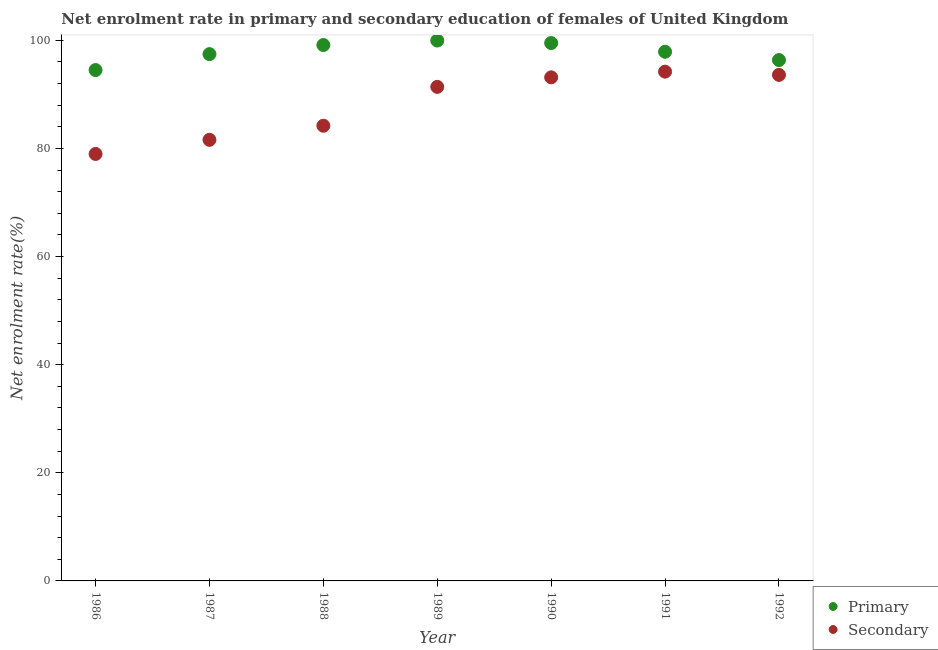What is the enrollment rate in primary education in 1987?
Provide a short and direct response. 97.44. Across all years, what is the maximum enrollment rate in secondary education?
Offer a terse response. 94.19. Across all years, what is the minimum enrollment rate in secondary education?
Offer a very short reply. 78.97. In which year was the enrollment rate in primary education maximum?
Keep it short and to the point. 1989. What is the total enrollment rate in secondary education in the graph?
Ensure brevity in your answer.  617.06. What is the difference between the enrollment rate in primary education in 1987 and that in 1988?
Give a very brief answer. -1.68. What is the difference between the enrollment rate in secondary education in 1989 and the enrollment rate in primary education in 1986?
Offer a very short reply. -3.11. What is the average enrollment rate in primary education per year?
Keep it short and to the point. 97.81. In the year 1988, what is the difference between the enrollment rate in primary education and enrollment rate in secondary education?
Your response must be concise. 14.93. In how many years, is the enrollment rate in primary education greater than 4 %?
Offer a terse response. 7. What is the ratio of the enrollment rate in secondary education in 1988 to that in 1989?
Your response must be concise. 0.92. Is the enrollment rate in secondary education in 1987 less than that in 1992?
Your answer should be compact. Yes. What is the difference between the highest and the second highest enrollment rate in secondary education?
Offer a terse response. 0.6. What is the difference between the highest and the lowest enrollment rate in secondary education?
Your response must be concise. 15.22. Is the sum of the enrollment rate in primary education in 1988 and 1992 greater than the maximum enrollment rate in secondary education across all years?
Offer a terse response. Yes. Does the enrollment rate in primary education monotonically increase over the years?
Make the answer very short. No. Is the enrollment rate in secondary education strictly greater than the enrollment rate in primary education over the years?
Your response must be concise. No. Is the enrollment rate in secondary education strictly less than the enrollment rate in primary education over the years?
Give a very brief answer. Yes. How many years are there in the graph?
Ensure brevity in your answer.  7. What is the difference between two consecutive major ticks on the Y-axis?
Your response must be concise. 20. Are the values on the major ticks of Y-axis written in scientific E-notation?
Ensure brevity in your answer.  No. Does the graph contain any zero values?
Keep it short and to the point. No. What is the title of the graph?
Offer a terse response. Net enrolment rate in primary and secondary education of females of United Kingdom. Does "Private consumption" appear as one of the legend labels in the graph?
Make the answer very short. No. What is the label or title of the X-axis?
Your response must be concise. Year. What is the label or title of the Y-axis?
Your answer should be very brief. Net enrolment rate(%). What is the Net enrolment rate(%) of Primary in 1986?
Give a very brief answer. 94.49. What is the Net enrolment rate(%) in Secondary in 1986?
Provide a short and direct response. 78.97. What is the Net enrolment rate(%) of Primary in 1987?
Offer a very short reply. 97.44. What is the Net enrolment rate(%) in Secondary in 1987?
Ensure brevity in your answer.  81.59. What is the Net enrolment rate(%) of Primary in 1988?
Your answer should be very brief. 99.12. What is the Net enrolment rate(%) in Secondary in 1988?
Your answer should be compact. 84.19. What is the Net enrolment rate(%) of Primary in 1989?
Ensure brevity in your answer.  99.95. What is the Net enrolment rate(%) in Secondary in 1989?
Keep it short and to the point. 91.38. What is the Net enrolment rate(%) of Primary in 1990?
Make the answer very short. 99.48. What is the Net enrolment rate(%) of Secondary in 1990?
Your answer should be compact. 93.14. What is the Net enrolment rate(%) of Primary in 1991?
Your answer should be very brief. 97.87. What is the Net enrolment rate(%) of Secondary in 1991?
Your response must be concise. 94.19. What is the Net enrolment rate(%) of Primary in 1992?
Provide a succinct answer. 96.34. What is the Net enrolment rate(%) of Secondary in 1992?
Make the answer very short. 93.59. Across all years, what is the maximum Net enrolment rate(%) in Primary?
Provide a short and direct response. 99.95. Across all years, what is the maximum Net enrolment rate(%) of Secondary?
Your answer should be very brief. 94.19. Across all years, what is the minimum Net enrolment rate(%) of Primary?
Offer a terse response. 94.49. Across all years, what is the minimum Net enrolment rate(%) in Secondary?
Your answer should be very brief. 78.97. What is the total Net enrolment rate(%) of Primary in the graph?
Offer a terse response. 684.69. What is the total Net enrolment rate(%) of Secondary in the graph?
Offer a very short reply. 617.06. What is the difference between the Net enrolment rate(%) in Primary in 1986 and that in 1987?
Your answer should be very brief. -2.95. What is the difference between the Net enrolment rate(%) in Secondary in 1986 and that in 1987?
Give a very brief answer. -2.61. What is the difference between the Net enrolment rate(%) of Primary in 1986 and that in 1988?
Offer a terse response. -4.63. What is the difference between the Net enrolment rate(%) in Secondary in 1986 and that in 1988?
Provide a short and direct response. -5.22. What is the difference between the Net enrolment rate(%) in Primary in 1986 and that in 1989?
Your answer should be very brief. -5.46. What is the difference between the Net enrolment rate(%) in Secondary in 1986 and that in 1989?
Keep it short and to the point. -12.41. What is the difference between the Net enrolment rate(%) in Primary in 1986 and that in 1990?
Offer a very short reply. -4.99. What is the difference between the Net enrolment rate(%) of Secondary in 1986 and that in 1990?
Provide a succinct answer. -14.17. What is the difference between the Net enrolment rate(%) in Primary in 1986 and that in 1991?
Provide a short and direct response. -3.38. What is the difference between the Net enrolment rate(%) of Secondary in 1986 and that in 1991?
Keep it short and to the point. -15.22. What is the difference between the Net enrolment rate(%) in Primary in 1986 and that in 1992?
Your answer should be very brief. -1.85. What is the difference between the Net enrolment rate(%) of Secondary in 1986 and that in 1992?
Your answer should be very brief. -14.62. What is the difference between the Net enrolment rate(%) of Primary in 1987 and that in 1988?
Give a very brief answer. -1.68. What is the difference between the Net enrolment rate(%) in Secondary in 1987 and that in 1988?
Your answer should be compact. -2.61. What is the difference between the Net enrolment rate(%) in Primary in 1987 and that in 1989?
Provide a succinct answer. -2.51. What is the difference between the Net enrolment rate(%) in Secondary in 1987 and that in 1989?
Keep it short and to the point. -9.79. What is the difference between the Net enrolment rate(%) of Primary in 1987 and that in 1990?
Offer a terse response. -2.05. What is the difference between the Net enrolment rate(%) of Secondary in 1987 and that in 1990?
Your answer should be compact. -11.56. What is the difference between the Net enrolment rate(%) of Primary in 1987 and that in 1991?
Give a very brief answer. -0.43. What is the difference between the Net enrolment rate(%) in Secondary in 1987 and that in 1991?
Your answer should be compact. -12.61. What is the difference between the Net enrolment rate(%) of Primary in 1987 and that in 1992?
Offer a terse response. 1.1. What is the difference between the Net enrolment rate(%) of Secondary in 1987 and that in 1992?
Provide a short and direct response. -12.01. What is the difference between the Net enrolment rate(%) in Primary in 1988 and that in 1989?
Ensure brevity in your answer.  -0.83. What is the difference between the Net enrolment rate(%) in Secondary in 1988 and that in 1989?
Provide a succinct answer. -7.19. What is the difference between the Net enrolment rate(%) in Primary in 1988 and that in 1990?
Make the answer very short. -0.37. What is the difference between the Net enrolment rate(%) in Secondary in 1988 and that in 1990?
Provide a succinct answer. -8.95. What is the difference between the Net enrolment rate(%) in Primary in 1988 and that in 1991?
Offer a very short reply. 1.25. What is the difference between the Net enrolment rate(%) in Secondary in 1988 and that in 1991?
Ensure brevity in your answer.  -10. What is the difference between the Net enrolment rate(%) in Primary in 1988 and that in 1992?
Give a very brief answer. 2.78. What is the difference between the Net enrolment rate(%) of Secondary in 1988 and that in 1992?
Your answer should be compact. -9.4. What is the difference between the Net enrolment rate(%) of Primary in 1989 and that in 1990?
Provide a succinct answer. 0.46. What is the difference between the Net enrolment rate(%) in Secondary in 1989 and that in 1990?
Offer a terse response. -1.76. What is the difference between the Net enrolment rate(%) of Primary in 1989 and that in 1991?
Provide a succinct answer. 2.08. What is the difference between the Net enrolment rate(%) in Secondary in 1989 and that in 1991?
Ensure brevity in your answer.  -2.82. What is the difference between the Net enrolment rate(%) in Primary in 1989 and that in 1992?
Keep it short and to the point. 3.61. What is the difference between the Net enrolment rate(%) of Secondary in 1989 and that in 1992?
Provide a short and direct response. -2.22. What is the difference between the Net enrolment rate(%) of Primary in 1990 and that in 1991?
Your response must be concise. 1.61. What is the difference between the Net enrolment rate(%) of Secondary in 1990 and that in 1991?
Offer a terse response. -1.05. What is the difference between the Net enrolment rate(%) in Primary in 1990 and that in 1992?
Make the answer very short. 3.15. What is the difference between the Net enrolment rate(%) in Secondary in 1990 and that in 1992?
Provide a short and direct response. -0.45. What is the difference between the Net enrolment rate(%) of Primary in 1991 and that in 1992?
Make the answer very short. 1.53. What is the difference between the Net enrolment rate(%) of Secondary in 1991 and that in 1992?
Ensure brevity in your answer.  0.6. What is the difference between the Net enrolment rate(%) in Primary in 1986 and the Net enrolment rate(%) in Secondary in 1987?
Ensure brevity in your answer.  12.91. What is the difference between the Net enrolment rate(%) in Primary in 1986 and the Net enrolment rate(%) in Secondary in 1988?
Your answer should be compact. 10.3. What is the difference between the Net enrolment rate(%) in Primary in 1986 and the Net enrolment rate(%) in Secondary in 1989?
Provide a succinct answer. 3.11. What is the difference between the Net enrolment rate(%) of Primary in 1986 and the Net enrolment rate(%) of Secondary in 1990?
Your answer should be very brief. 1.35. What is the difference between the Net enrolment rate(%) in Primary in 1986 and the Net enrolment rate(%) in Secondary in 1991?
Your answer should be very brief. 0.3. What is the difference between the Net enrolment rate(%) in Primary in 1986 and the Net enrolment rate(%) in Secondary in 1992?
Your response must be concise. 0.9. What is the difference between the Net enrolment rate(%) of Primary in 1987 and the Net enrolment rate(%) of Secondary in 1988?
Give a very brief answer. 13.25. What is the difference between the Net enrolment rate(%) of Primary in 1987 and the Net enrolment rate(%) of Secondary in 1989?
Give a very brief answer. 6.06. What is the difference between the Net enrolment rate(%) of Primary in 1987 and the Net enrolment rate(%) of Secondary in 1990?
Your answer should be compact. 4.29. What is the difference between the Net enrolment rate(%) in Primary in 1987 and the Net enrolment rate(%) in Secondary in 1991?
Your answer should be compact. 3.24. What is the difference between the Net enrolment rate(%) in Primary in 1987 and the Net enrolment rate(%) in Secondary in 1992?
Offer a very short reply. 3.84. What is the difference between the Net enrolment rate(%) of Primary in 1988 and the Net enrolment rate(%) of Secondary in 1989?
Keep it short and to the point. 7.74. What is the difference between the Net enrolment rate(%) of Primary in 1988 and the Net enrolment rate(%) of Secondary in 1990?
Provide a short and direct response. 5.97. What is the difference between the Net enrolment rate(%) of Primary in 1988 and the Net enrolment rate(%) of Secondary in 1991?
Offer a very short reply. 4.92. What is the difference between the Net enrolment rate(%) of Primary in 1988 and the Net enrolment rate(%) of Secondary in 1992?
Keep it short and to the point. 5.52. What is the difference between the Net enrolment rate(%) of Primary in 1989 and the Net enrolment rate(%) of Secondary in 1990?
Keep it short and to the point. 6.8. What is the difference between the Net enrolment rate(%) of Primary in 1989 and the Net enrolment rate(%) of Secondary in 1991?
Keep it short and to the point. 5.75. What is the difference between the Net enrolment rate(%) in Primary in 1989 and the Net enrolment rate(%) in Secondary in 1992?
Offer a very short reply. 6.35. What is the difference between the Net enrolment rate(%) in Primary in 1990 and the Net enrolment rate(%) in Secondary in 1991?
Your answer should be very brief. 5.29. What is the difference between the Net enrolment rate(%) of Primary in 1990 and the Net enrolment rate(%) of Secondary in 1992?
Keep it short and to the point. 5.89. What is the difference between the Net enrolment rate(%) of Primary in 1991 and the Net enrolment rate(%) of Secondary in 1992?
Keep it short and to the point. 4.28. What is the average Net enrolment rate(%) in Primary per year?
Make the answer very short. 97.81. What is the average Net enrolment rate(%) in Secondary per year?
Provide a short and direct response. 88.15. In the year 1986, what is the difference between the Net enrolment rate(%) of Primary and Net enrolment rate(%) of Secondary?
Your answer should be very brief. 15.52. In the year 1987, what is the difference between the Net enrolment rate(%) in Primary and Net enrolment rate(%) in Secondary?
Your answer should be compact. 15.85. In the year 1988, what is the difference between the Net enrolment rate(%) in Primary and Net enrolment rate(%) in Secondary?
Your answer should be very brief. 14.93. In the year 1989, what is the difference between the Net enrolment rate(%) in Primary and Net enrolment rate(%) in Secondary?
Provide a succinct answer. 8.57. In the year 1990, what is the difference between the Net enrolment rate(%) of Primary and Net enrolment rate(%) of Secondary?
Keep it short and to the point. 6.34. In the year 1991, what is the difference between the Net enrolment rate(%) in Primary and Net enrolment rate(%) in Secondary?
Provide a succinct answer. 3.68. In the year 1992, what is the difference between the Net enrolment rate(%) of Primary and Net enrolment rate(%) of Secondary?
Give a very brief answer. 2.74. What is the ratio of the Net enrolment rate(%) in Primary in 1986 to that in 1987?
Offer a terse response. 0.97. What is the ratio of the Net enrolment rate(%) in Primary in 1986 to that in 1988?
Your answer should be very brief. 0.95. What is the ratio of the Net enrolment rate(%) in Secondary in 1986 to that in 1988?
Your answer should be compact. 0.94. What is the ratio of the Net enrolment rate(%) in Primary in 1986 to that in 1989?
Your answer should be very brief. 0.95. What is the ratio of the Net enrolment rate(%) of Secondary in 1986 to that in 1989?
Your answer should be compact. 0.86. What is the ratio of the Net enrolment rate(%) of Primary in 1986 to that in 1990?
Provide a short and direct response. 0.95. What is the ratio of the Net enrolment rate(%) in Secondary in 1986 to that in 1990?
Your answer should be compact. 0.85. What is the ratio of the Net enrolment rate(%) of Primary in 1986 to that in 1991?
Offer a terse response. 0.97. What is the ratio of the Net enrolment rate(%) in Secondary in 1986 to that in 1991?
Your answer should be very brief. 0.84. What is the ratio of the Net enrolment rate(%) in Primary in 1986 to that in 1992?
Your answer should be compact. 0.98. What is the ratio of the Net enrolment rate(%) in Secondary in 1986 to that in 1992?
Give a very brief answer. 0.84. What is the ratio of the Net enrolment rate(%) of Primary in 1987 to that in 1988?
Your response must be concise. 0.98. What is the ratio of the Net enrolment rate(%) in Secondary in 1987 to that in 1988?
Offer a very short reply. 0.97. What is the ratio of the Net enrolment rate(%) in Primary in 1987 to that in 1989?
Make the answer very short. 0.97. What is the ratio of the Net enrolment rate(%) of Secondary in 1987 to that in 1989?
Provide a succinct answer. 0.89. What is the ratio of the Net enrolment rate(%) in Primary in 1987 to that in 1990?
Make the answer very short. 0.98. What is the ratio of the Net enrolment rate(%) of Secondary in 1987 to that in 1990?
Keep it short and to the point. 0.88. What is the ratio of the Net enrolment rate(%) in Primary in 1987 to that in 1991?
Your answer should be compact. 1. What is the ratio of the Net enrolment rate(%) of Secondary in 1987 to that in 1991?
Make the answer very short. 0.87. What is the ratio of the Net enrolment rate(%) of Primary in 1987 to that in 1992?
Provide a succinct answer. 1.01. What is the ratio of the Net enrolment rate(%) of Secondary in 1987 to that in 1992?
Provide a short and direct response. 0.87. What is the ratio of the Net enrolment rate(%) in Secondary in 1988 to that in 1989?
Offer a very short reply. 0.92. What is the ratio of the Net enrolment rate(%) in Secondary in 1988 to that in 1990?
Offer a terse response. 0.9. What is the ratio of the Net enrolment rate(%) in Primary in 1988 to that in 1991?
Give a very brief answer. 1.01. What is the ratio of the Net enrolment rate(%) of Secondary in 1988 to that in 1991?
Make the answer very short. 0.89. What is the ratio of the Net enrolment rate(%) of Primary in 1988 to that in 1992?
Keep it short and to the point. 1.03. What is the ratio of the Net enrolment rate(%) of Secondary in 1988 to that in 1992?
Ensure brevity in your answer.  0.9. What is the ratio of the Net enrolment rate(%) in Secondary in 1989 to that in 1990?
Your answer should be very brief. 0.98. What is the ratio of the Net enrolment rate(%) in Primary in 1989 to that in 1991?
Keep it short and to the point. 1.02. What is the ratio of the Net enrolment rate(%) in Secondary in 1989 to that in 1991?
Ensure brevity in your answer.  0.97. What is the ratio of the Net enrolment rate(%) in Primary in 1989 to that in 1992?
Ensure brevity in your answer.  1.04. What is the ratio of the Net enrolment rate(%) in Secondary in 1989 to that in 1992?
Make the answer very short. 0.98. What is the ratio of the Net enrolment rate(%) in Primary in 1990 to that in 1991?
Keep it short and to the point. 1.02. What is the ratio of the Net enrolment rate(%) of Primary in 1990 to that in 1992?
Offer a very short reply. 1.03. What is the ratio of the Net enrolment rate(%) in Secondary in 1990 to that in 1992?
Offer a terse response. 1. What is the ratio of the Net enrolment rate(%) of Primary in 1991 to that in 1992?
Make the answer very short. 1.02. What is the ratio of the Net enrolment rate(%) of Secondary in 1991 to that in 1992?
Offer a very short reply. 1.01. What is the difference between the highest and the second highest Net enrolment rate(%) in Primary?
Offer a very short reply. 0.46. What is the difference between the highest and the second highest Net enrolment rate(%) of Secondary?
Ensure brevity in your answer.  0.6. What is the difference between the highest and the lowest Net enrolment rate(%) of Primary?
Give a very brief answer. 5.46. What is the difference between the highest and the lowest Net enrolment rate(%) of Secondary?
Your answer should be very brief. 15.22. 